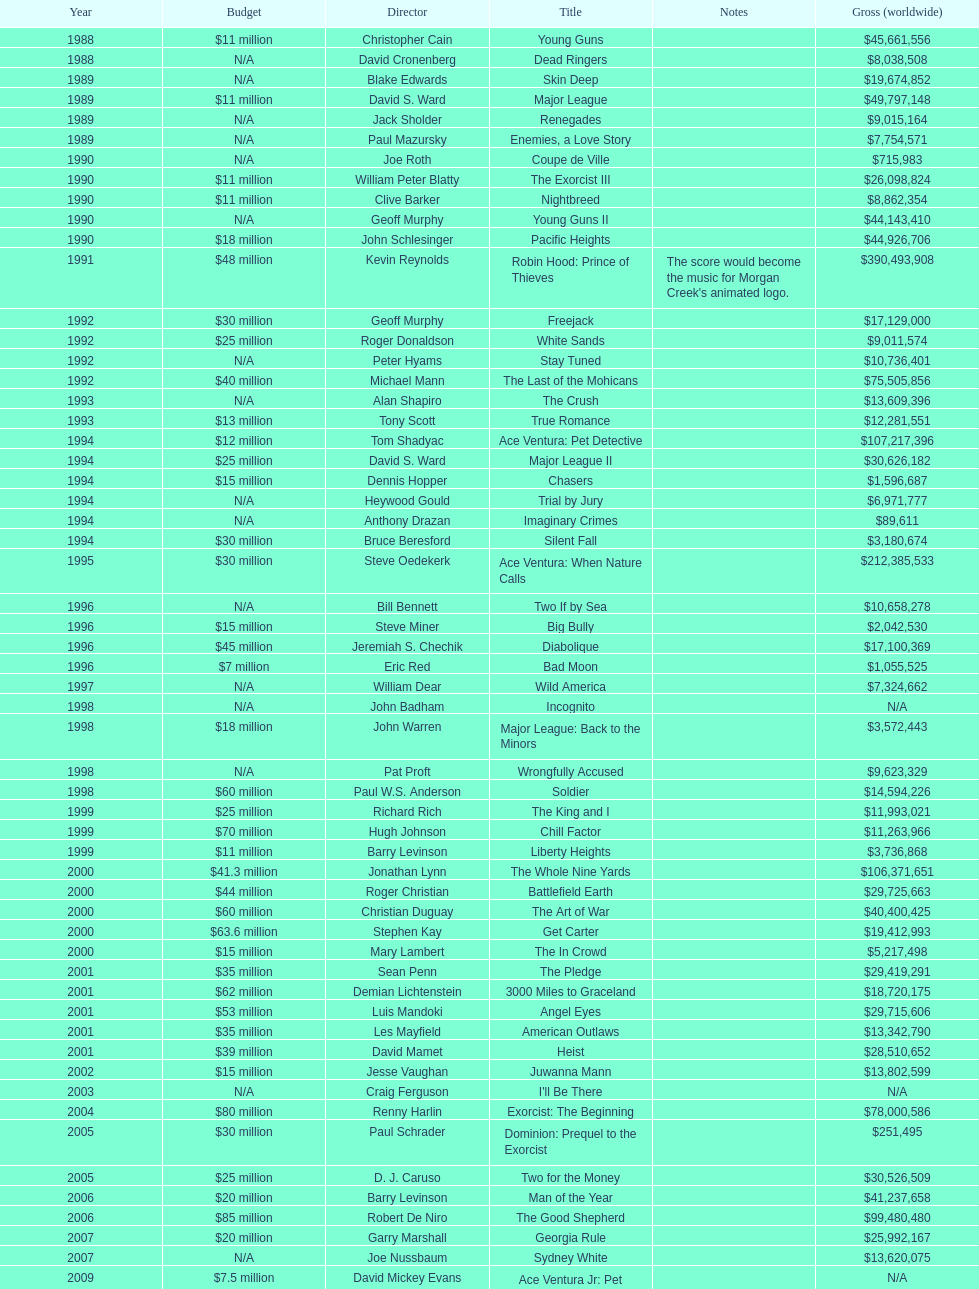Which morgan creek film grossed the most worldwide? Robin Hood: Prince of Thieves. 